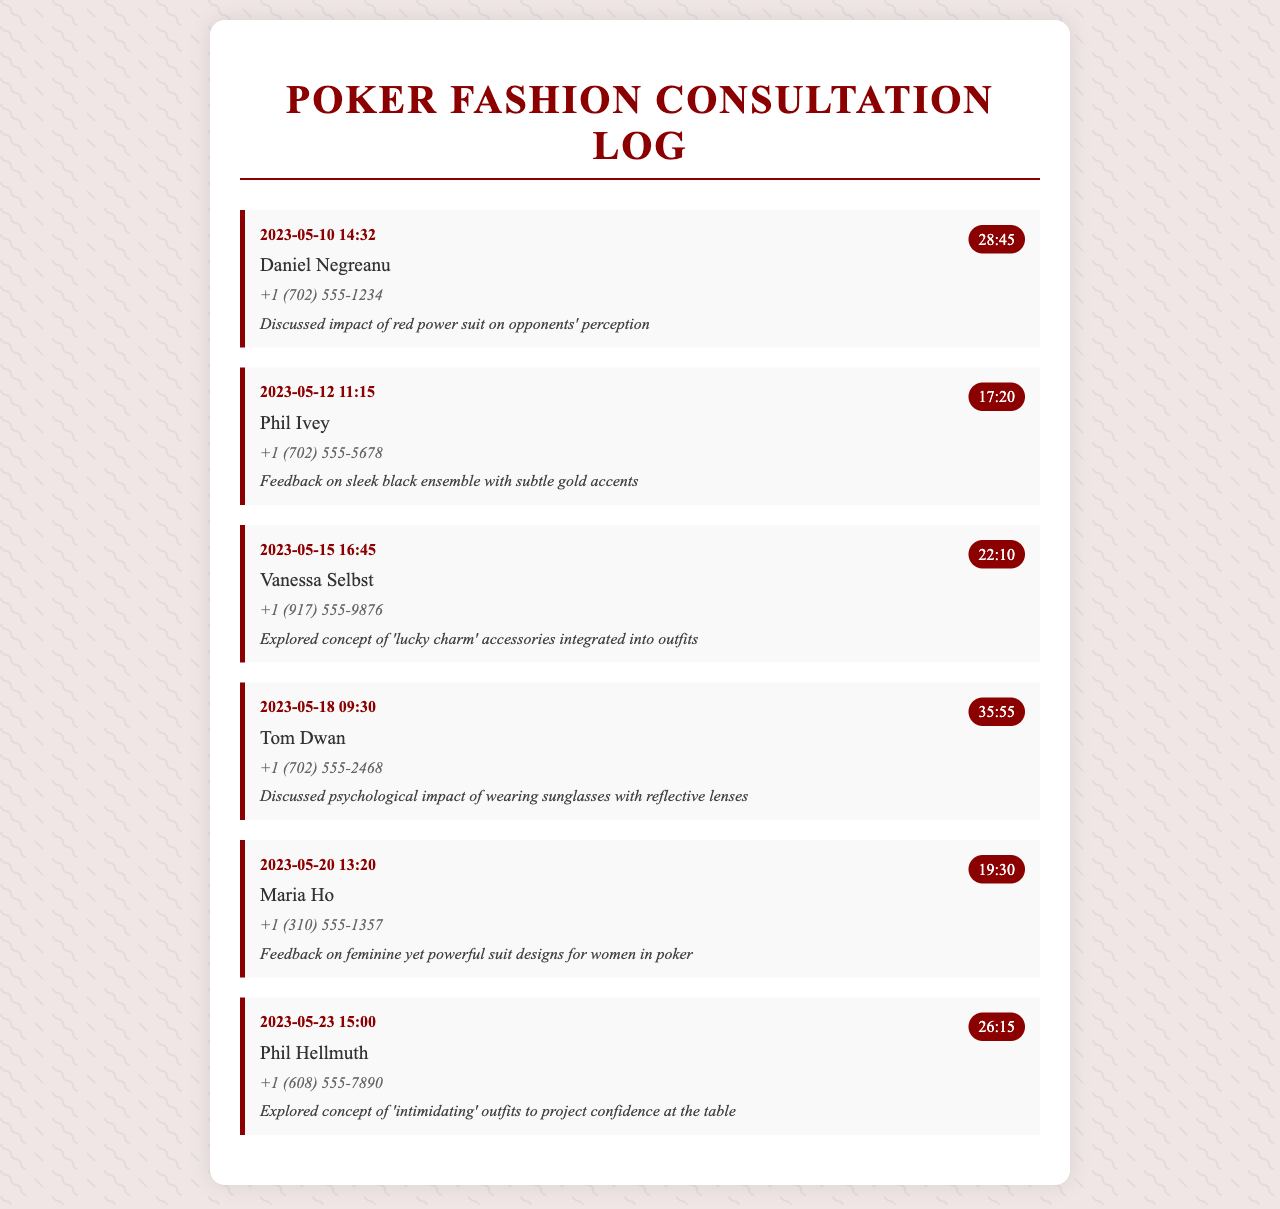What is the date of the call with Daniel Negreanu? The call with Daniel Negreanu took place on May 10, 2023.
Answer: May 10, 2023 How long was the conversation with Maria Ho? The duration of the call with Maria Ho was 19 minutes and 30 seconds.
Answer: 19:30 What was the main topic discussed with Phil Ivey? The main topic discussed with Phil Ivey was feedback on a sleek black ensemble with subtle gold accents.
Answer: sleek black ensemble with subtle gold accents Who discussed the impact of wearing sunglasses? Tom Dwan discussed the psychological impact of wearing sunglasses with reflective lenses.
Answer: Tom Dwan How many contacts are listed in the document? The document lists a total of six contacts.
Answer: six What is the common theme of the conversations in the document? The common theme is exploring the psychological and aesthetic impact of different outfits on high-stakes poker settings.
Answer: psychological and aesthetic impact of outfits What contact number belongs to Vanessa Selbst? The contact number for Vanessa Selbst is +1 (917) 555-9876.
Answer: +1 (917) 555-9876 What is the duration of the call with Phil Hellmuth? The call with Phil Hellmuth lasted 26 minutes and 15 seconds.
Answer: 26:15 